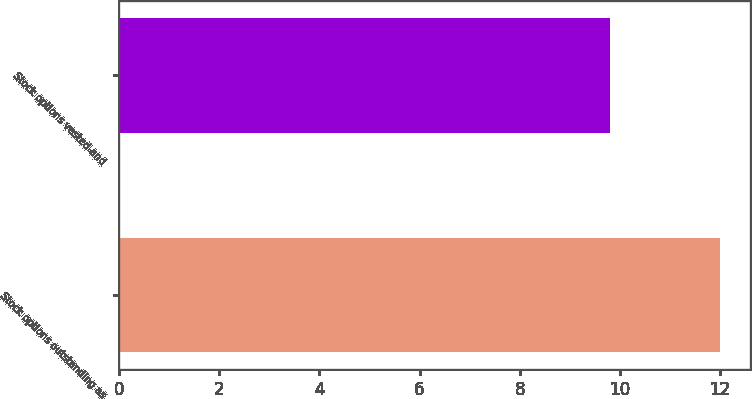Convert chart to OTSL. <chart><loc_0><loc_0><loc_500><loc_500><bar_chart><fcel>Stock options outstanding as<fcel>Stock options vested and<nl><fcel>12<fcel>9.8<nl></chart> 